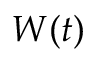<formula> <loc_0><loc_0><loc_500><loc_500>W ( t )</formula> 